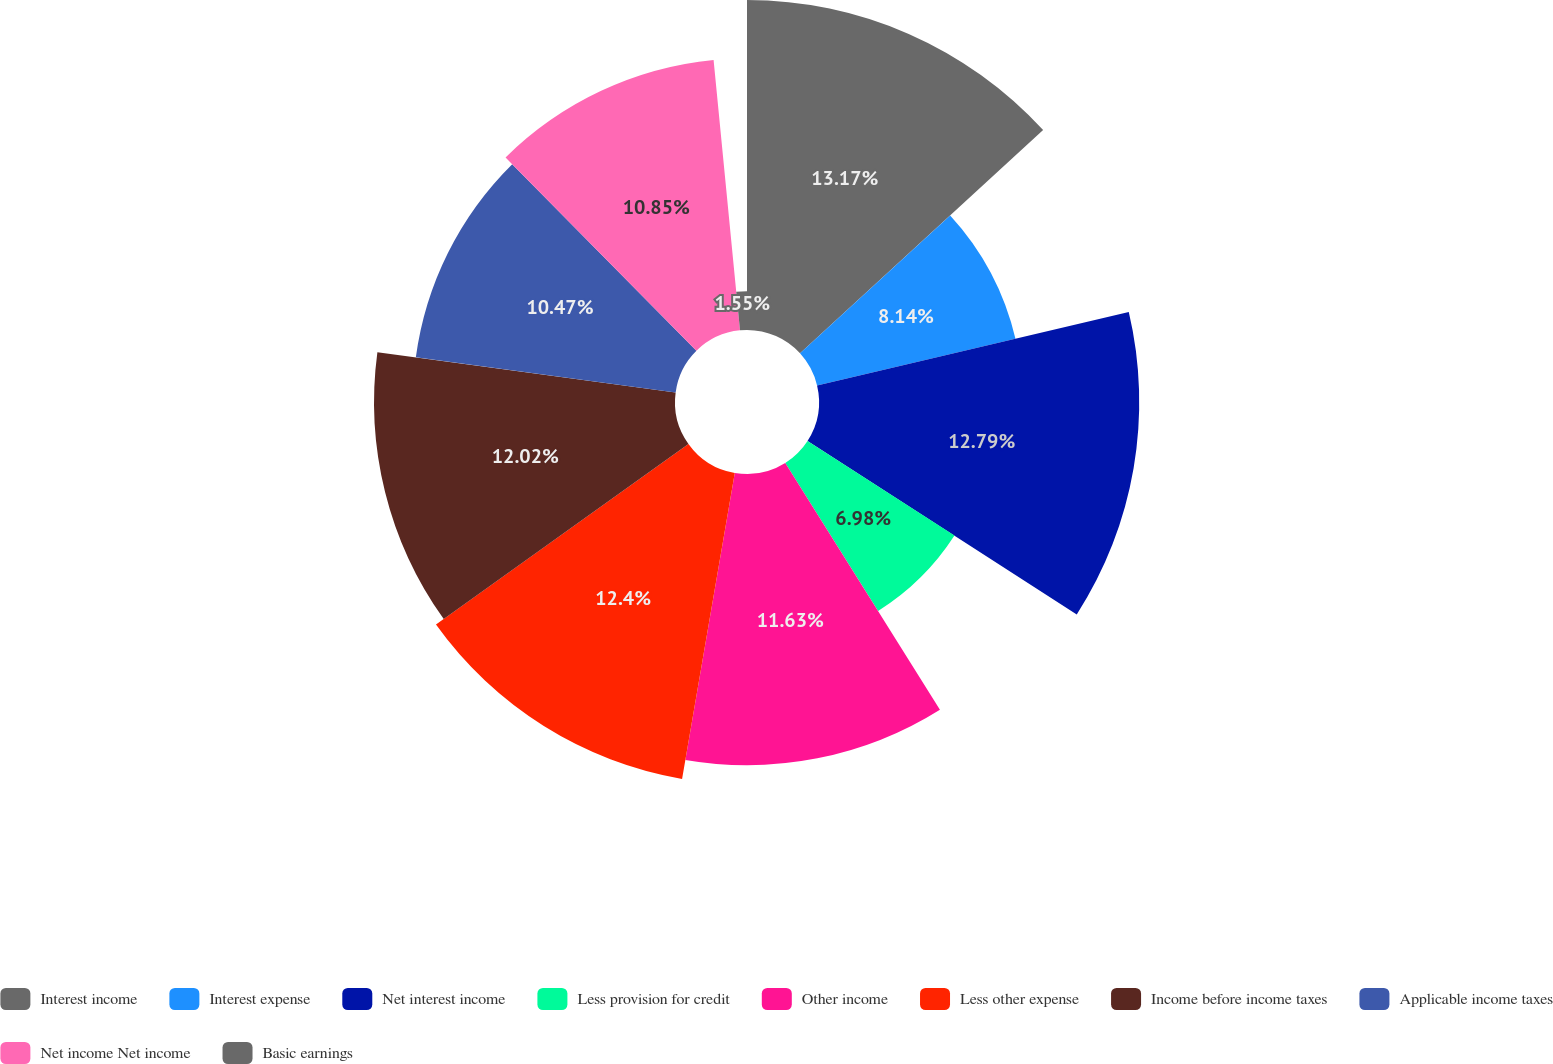Convert chart to OTSL. <chart><loc_0><loc_0><loc_500><loc_500><pie_chart><fcel>Interest income<fcel>Interest expense<fcel>Net interest income<fcel>Less provision for credit<fcel>Other income<fcel>Less other expense<fcel>Income before income taxes<fcel>Applicable income taxes<fcel>Net income Net income<fcel>Basic earnings<nl><fcel>13.18%<fcel>8.14%<fcel>12.79%<fcel>6.98%<fcel>11.63%<fcel>12.4%<fcel>12.02%<fcel>10.47%<fcel>10.85%<fcel>1.55%<nl></chart> 